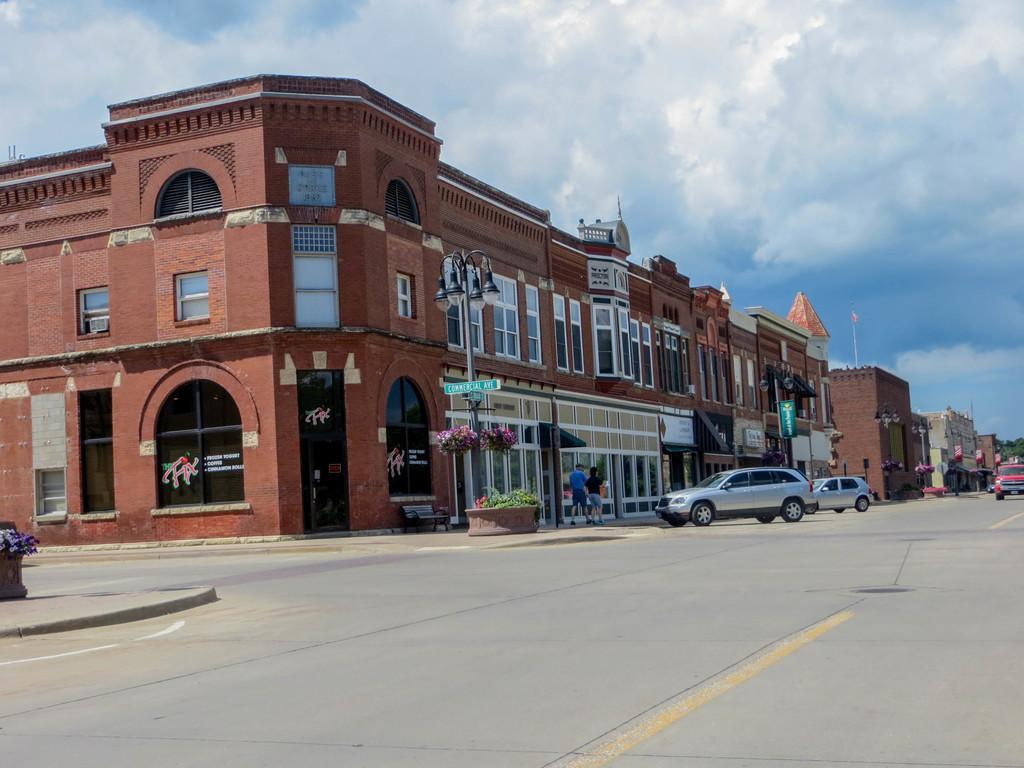In one or two sentences, can you explain what this image depicts? In this image in the center there are some buildings, vehicles and some persons are walking. And also i can see some boards, flower pots, plants and at the bottom there is road. At the top of the image there is sky. 